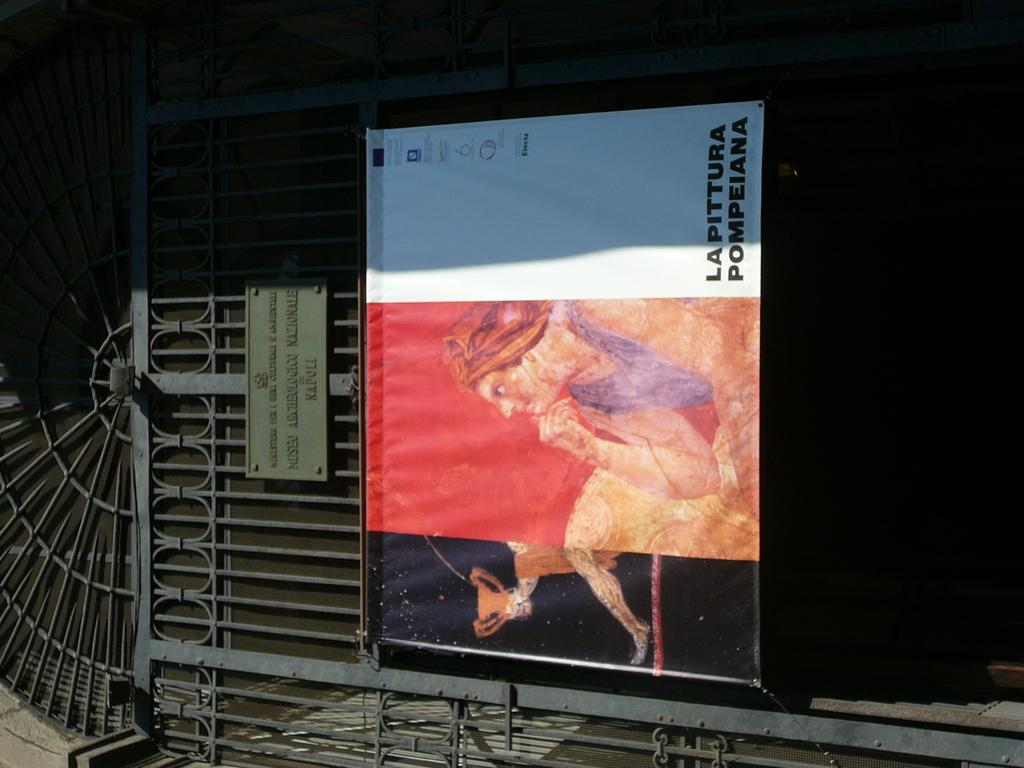Provide a one-sentence caption for the provided image. A sign has vertical text reading Lapittura Pompeiana. 